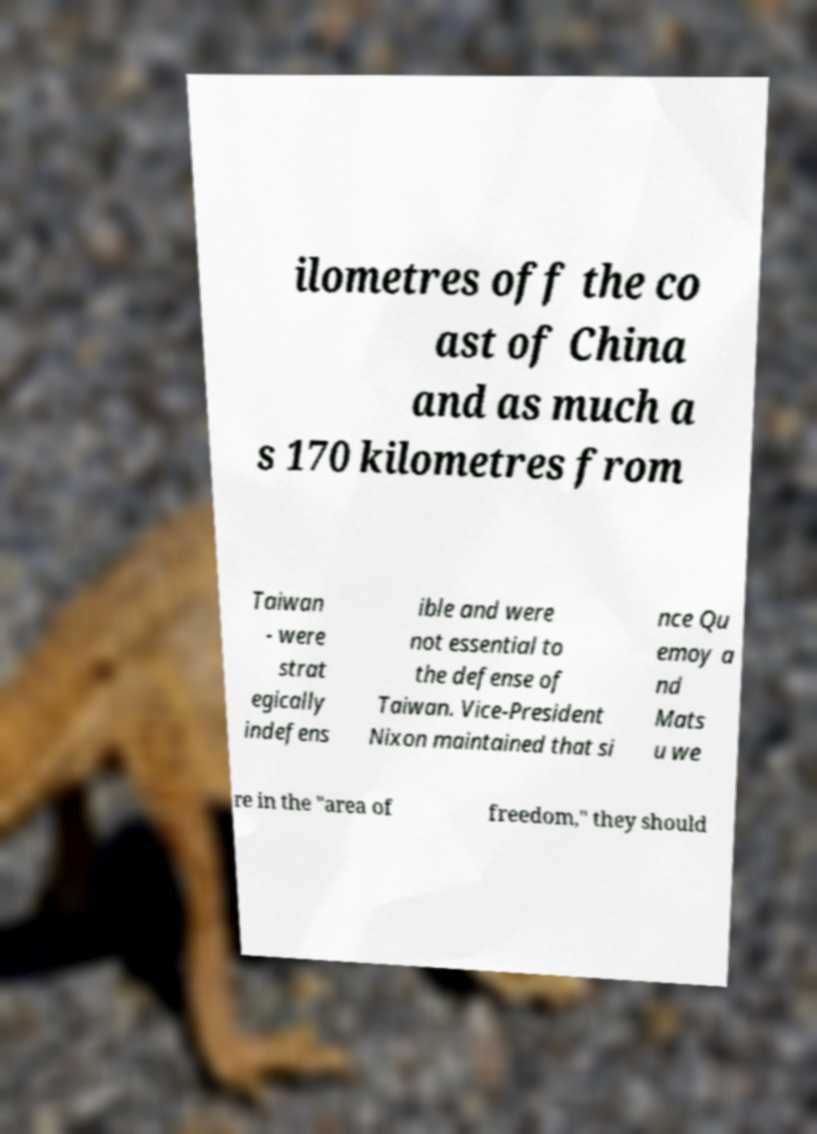For documentation purposes, I need the text within this image transcribed. Could you provide that? ilometres off the co ast of China and as much a s 170 kilometres from Taiwan - were strat egically indefens ible and were not essential to the defense of Taiwan. Vice-President Nixon maintained that si nce Qu emoy a nd Mats u we re in the "area of freedom," they should 